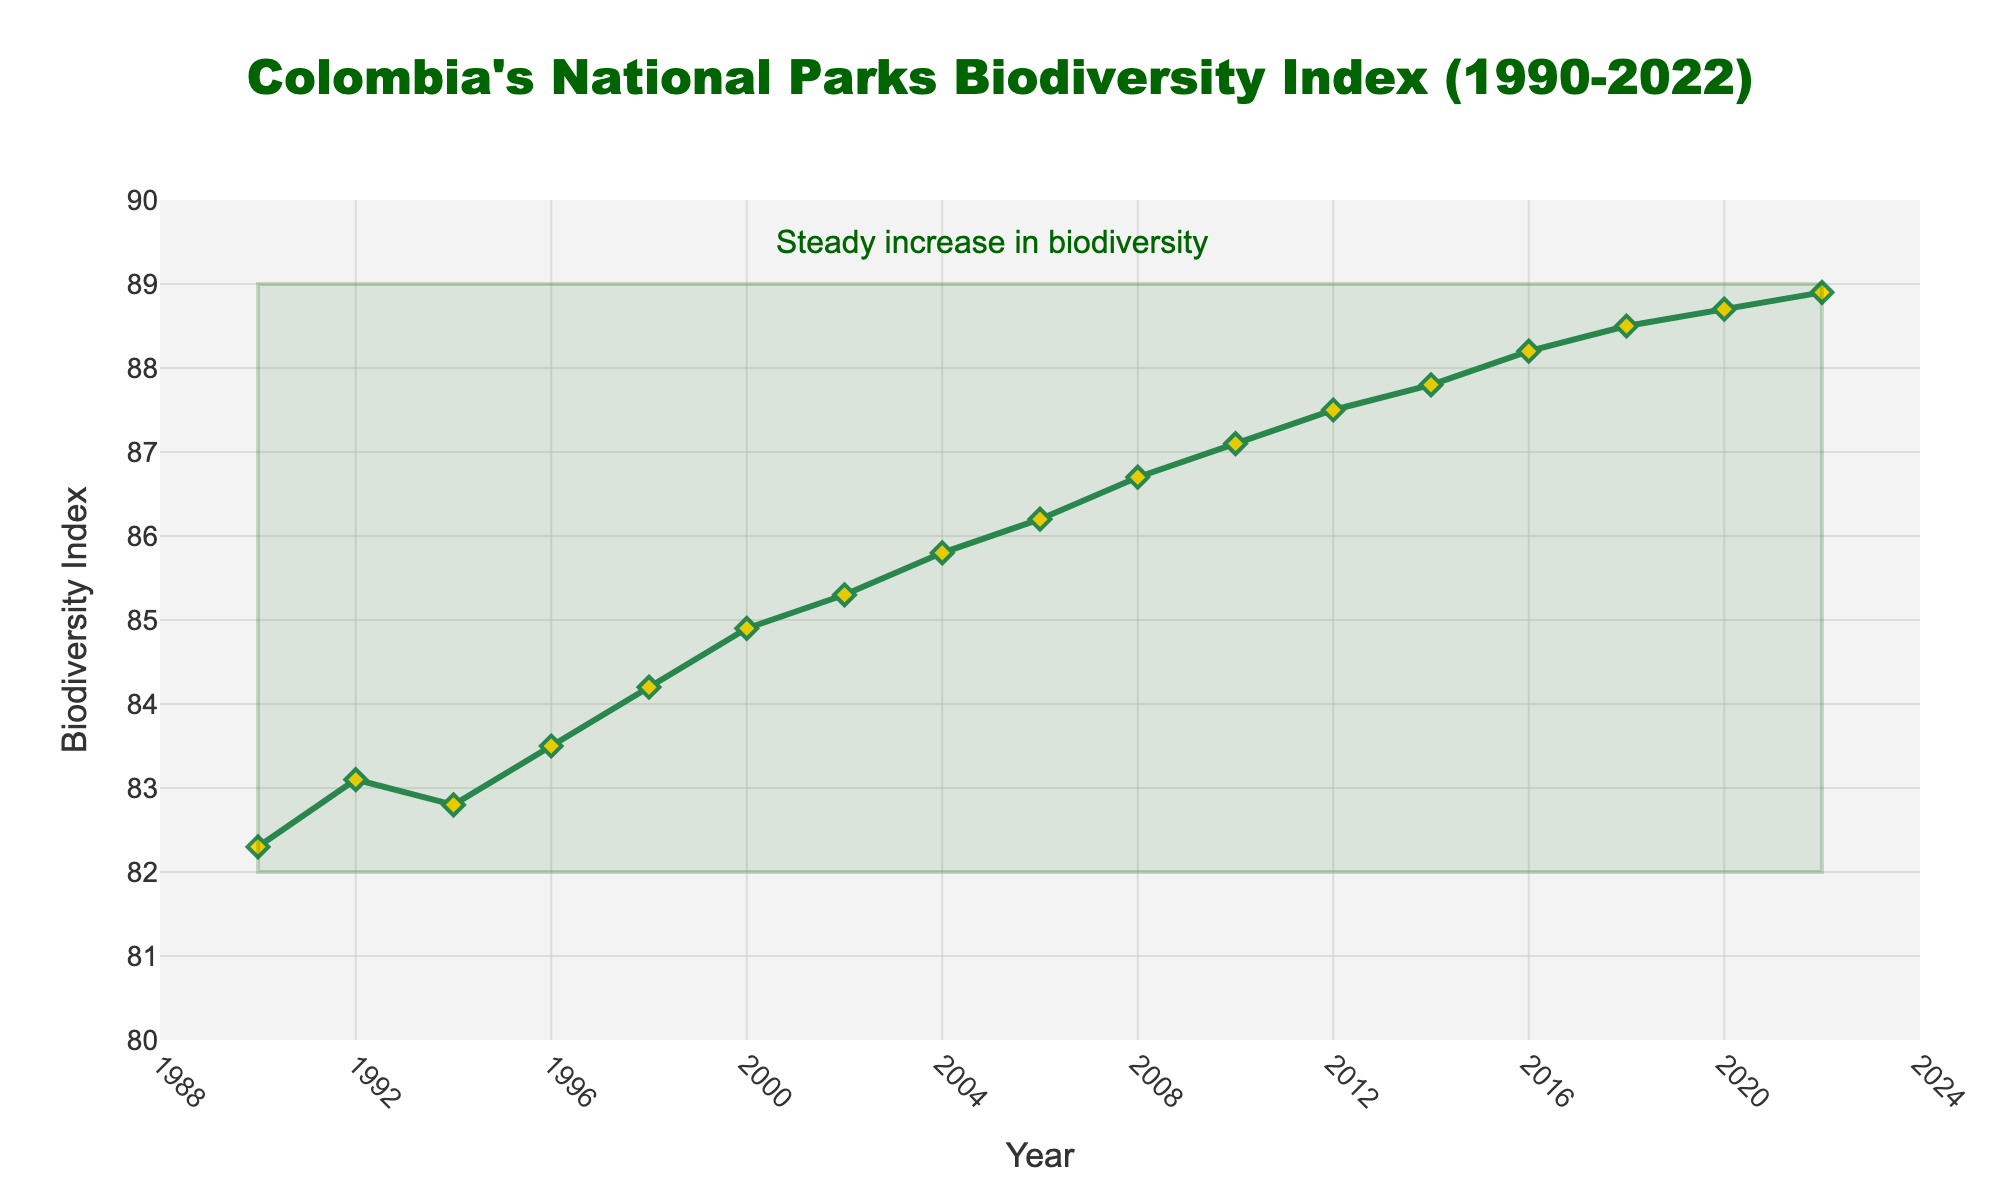What is the range of the Biodiversity Index from 1990 to 2022? To find the range, we subtract the minimum value from the maximum value. From the figure, the minimum Biodiversity Index is 82.3, and the maximum is 88.9. Thus, the range is 88.9 - 82.3 = 6.6.
Answer: 6.6 Between which years did the Biodiversity Index increase the most? To determine the years with the most significant increase, we look for the largest vertical difference between consecutive points. The largest difference is between 2018 (88.5) and 2020 (88.7), resulting in an increase of 0.2 units.
Answer: 2018-2020 What was the Biodiversity Index in the year 2000? By locating the point on the line chart corresponding to the year 2000, we see that the Biodiversity Index is marked at 84.9.
Answer: 84.9 Did the Biodiversity Index ever decrease between any two consecutive recorded years? To answer this, we check if there are any downward slopes between consecutive points. The index shows a consistent increasing trend, with no decreases between years.
Answer: No What is the average Biodiversity Index from 1990 to 2022? To find the average, sum all recorded Biodiversity Index values and divide by the number of recorded years. The sum is (82.3+83.1+82.8+83.5+84.2+84.9+85.3+85.8+86.2+86.7+87.1+87.5+87.8+88.2+88.5+88.7+88.9) = 1480.5. The average is 1480.5 / 17 = 87.085.
Answer: 87.085 How many years did it take for the Biodiversity Index to surpass 85 for the first time? Find the year the Biodiversity Index first exceeds 85. From the visual, it first surpasses 85 in 2002. Thus, it took from 1990 to 2002, which is 2002 - 1990 = 12 years.
Answer: 12 By what percentage did the Biodiversity Index increase from 1990 to 2022? First, find the initial and final values: 82.3 in 1990 and 88.9 in 2022. The percentage increase is calculated as ((88.9 - 82.3) / 82.3) * 100 = 8.02%.
Answer: 8.02% Which year shows a noticeable annotation about biodiversity trends, and what does it indicate? The annotation is located at 2005 and indicates a steady increase in biodiversity. The text around the annotation explicitly states this trend.
Answer: 2005 What period shows the most consistent increase in the Biodiversity Index? Observe periods where the index consistently rises without fluctuation. From 2002 to 2022, the index increases steadily without any decrease.
Answer: 2002-2022 What is the difference in Biodiversity Index between the years 2000 and 2004? From the chart, the Biodiversity Index in 2000 is 84.9, and in 2004 it is 85.8. The difference is 85.8 - 84.9 = 0.9.
Answer: 0.9 